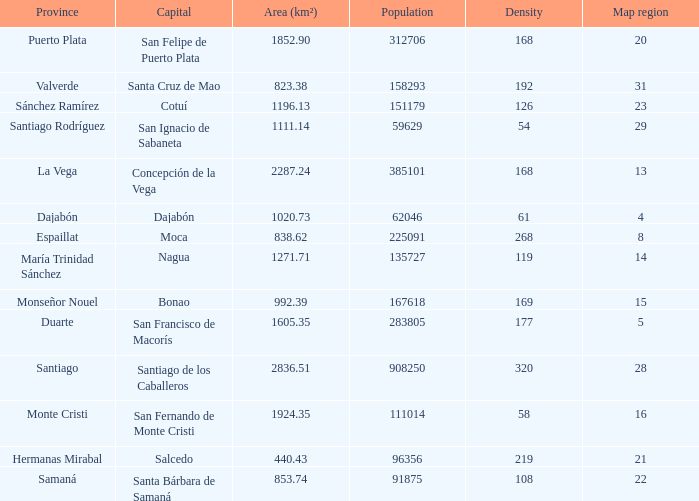Nagua has the area (km²) of? 1271.71. 